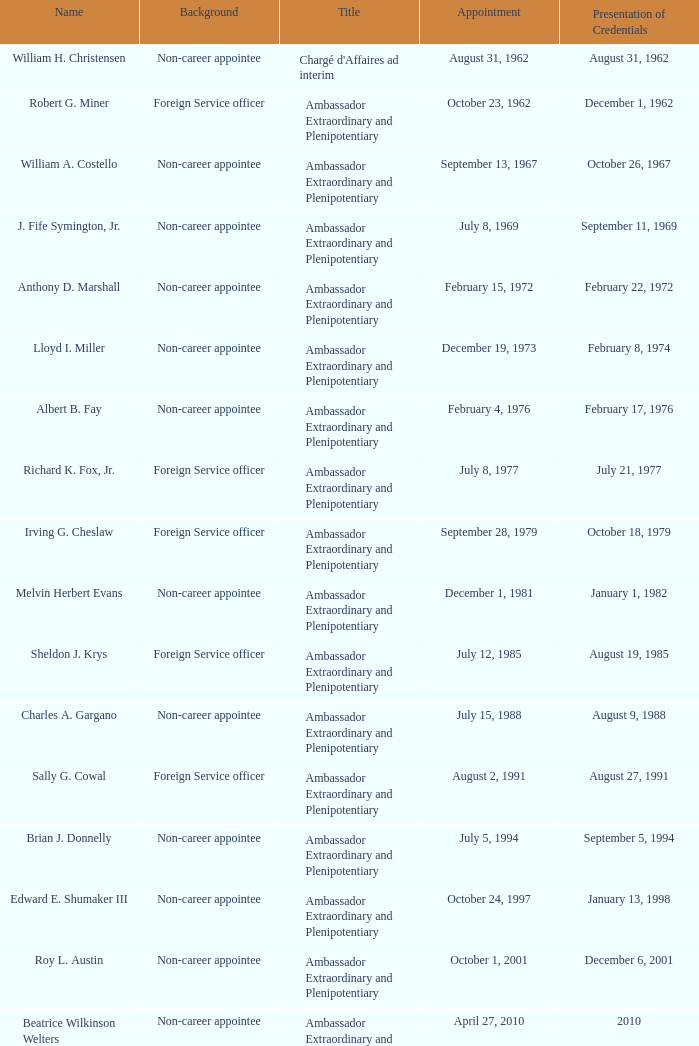When did robert g. miner display his certificates? December 1, 1962. 